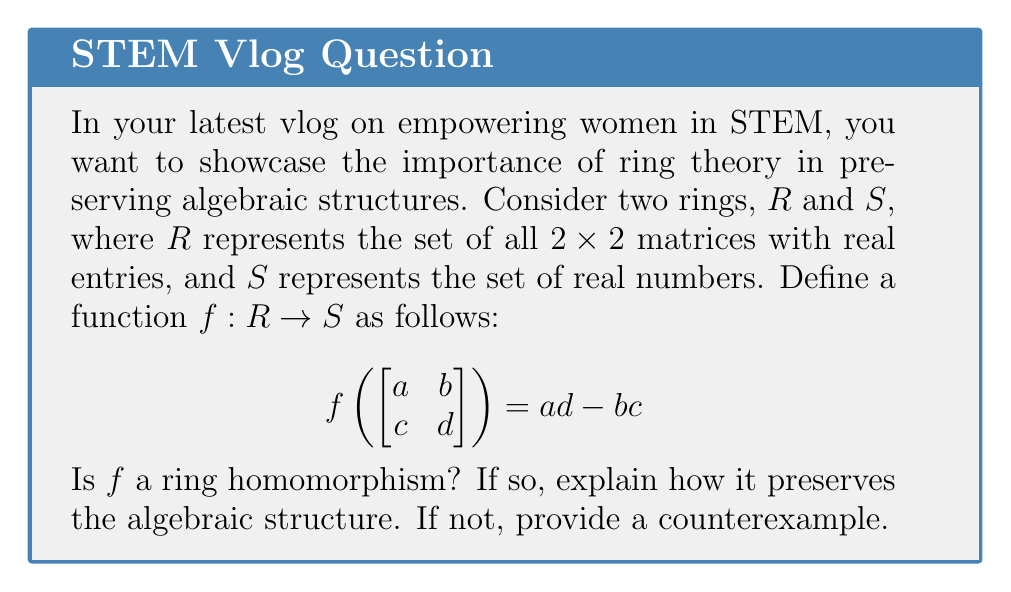Help me with this question. To determine if $f$ is a ring homomorphism, we need to check if it satisfies the following properties for all $x, y \in R$:

1. $f(x + y) = f(x) + f(y)$
2. $f(xy) = f(x)f(y)$
3. $f(1_R) = 1_S$

Let's check each property:

1. Addition preservation:
Let $x = \begin{bmatrix} a & b \\ c & d \end{bmatrix}$ and $y = \begin{bmatrix} e & f \\ g & h \end{bmatrix}$

$f(x + y) = f\left(\begin{bmatrix} a+e & b+f \\ c+g & d+h \end{bmatrix}\right) = (a+e)(d+h) - (b+f)(c+g)$
$= ad + ah + ed + eh - bc - bg - fc - fg$

$f(x) + f(y) = (ad - bc) + (eh - fg)$

These are not equal in general, so property 1 is not satisfied.

2. Multiplication preservation:
$f(xy) = f\left(\begin{bmatrix} ae+bg & af+bh \\ ce+dg & cf+dh \end{bmatrix}\right) = (ae+bg)(cf+dh) - (af+bh)(ce+dg)$
$= acef + adeh + bcfg + bdgh - acef - adeg - bcfh - bdfg$
$= adeh + bdgh - adeg - bcfh$

$f(x)f(y) = (ad-bc)(eh-fg) = adeh - adfg - bceh + bcfg$

These are not equal in general, so property 2 is not satisfied.

3. Identity preservation:
$f(1_R) = f\left(\begin{bmatrix} 1 & 0 \\ 0 & 1 \end{bmatrix}\right) = 1 \cdot 1 - 0 \cdot 0 = 1 = 1_S$

This property is satisfied.

Since properties 1 and 2 are not satisfied, $f$ is not a ring homomorphism. A specific counterexample for property 1:

Let $x = \begin{bmatrix} 1 & 0 \\ 0 & 1 \end{bmatrix}$ and $y = \begin{bmatrix} 0 & 1 \\ 1 & 0 \end{bmatrix}$

$f(x + y) = f\left(\begin{bmatrix} 1 & 1 \\ 1 & 1 \end{bmatrix}\right) = 1 \cdot 1 - 1 \cdot 1 = 0$

$f(x) + f(y) = (1 \cdot 1 - 0 \cdot 0) + (0 \cdot 0 - 1 \cdot 1) = 1 - 1 = 0$

In this case, the property holds, but it doesn't hold for all matrices in general.
Answer: No, $f$ is not a ring homomorphism. 